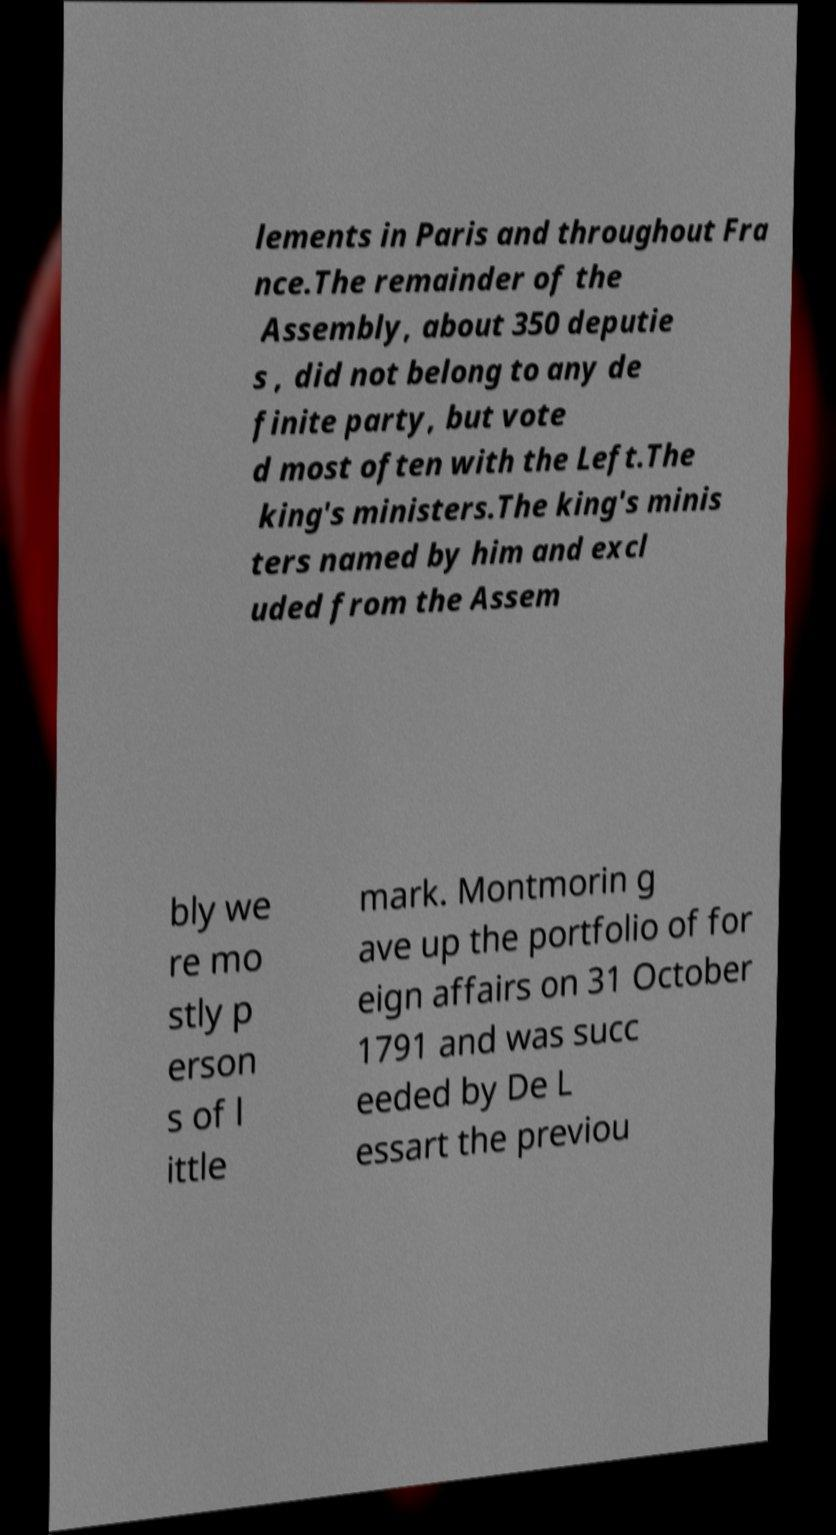Can you read and provide the text displayed in the image?This photo seems to have some interesting text. Can you extract and type it out for me? lements in Paris and throughout Fra nce.The remainder of the Assembly, about 350 deputie s , did not belong to any de finite party, but vote d most often with the Left.The king's ministers.The king's minis ters named by him and excl uded from the Assem bly we re mo stly p erson s of l ittle mark. Montmorin g ave up the portfolio of for eign affairs on 31 October 1791 and was succ eeded by De L essart the previou 